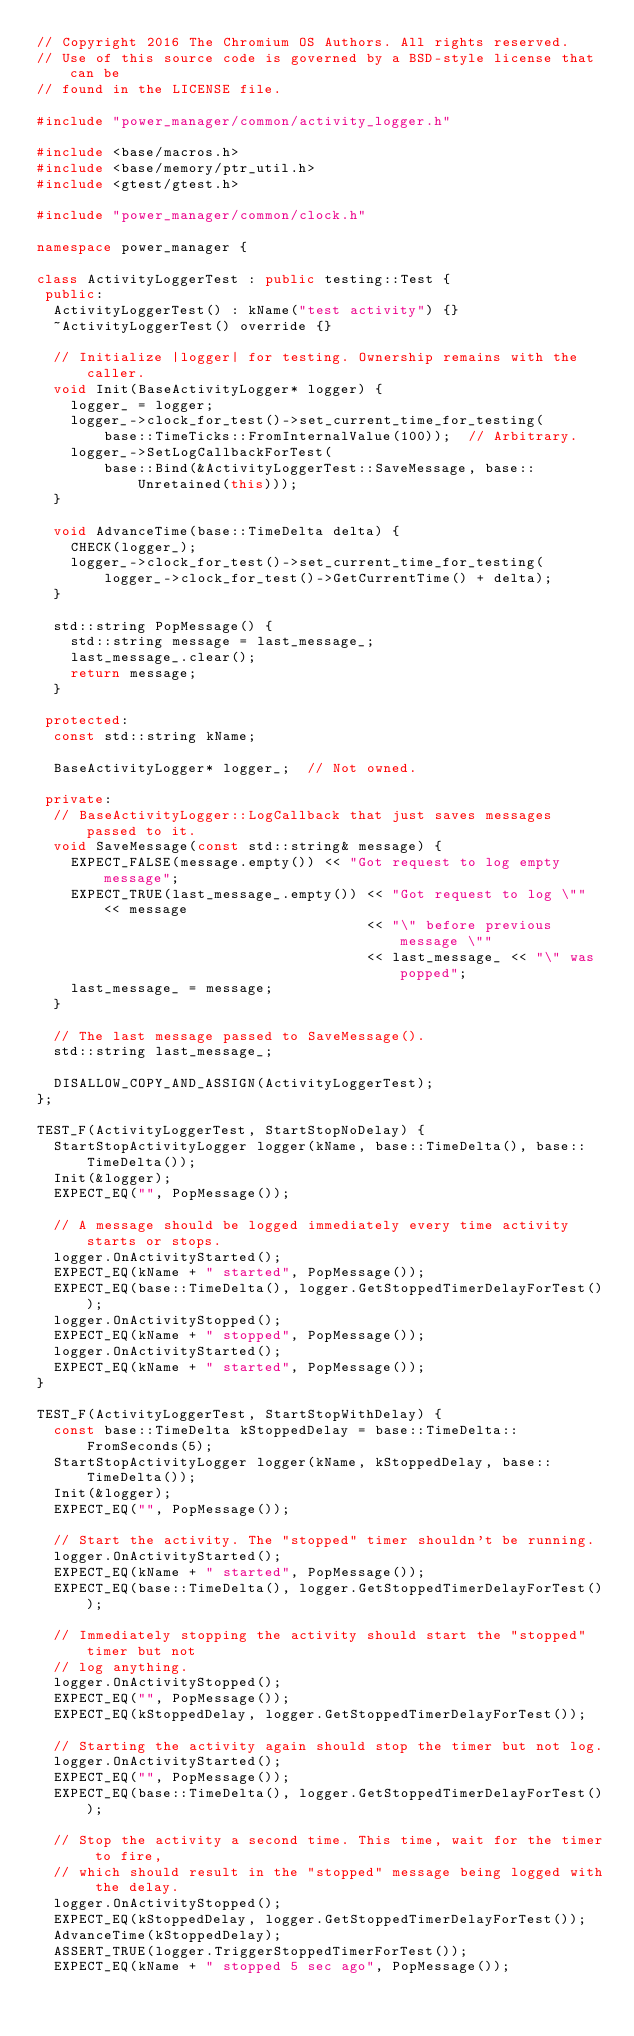Convert code to text. <code><loc_0><loc_0><loc_500><loc_500><_C++_>// Copyright 2016 The Chromium OS Authors. All rights reserved.
// Use of this source code is governed by a BSD-style license that can be
// found in the LICENSE file.

#include "power_manager/common/activity_logger.h"

#include <base/macros.h>
#include <base/memory/ptr_util.h>
#include <gtest/gtest.h>

#include "power_manager/common/clock.h"

namespace power_manager {

class ActivityLoggerTest : public testing::Test {
 public:
  ActivityLoggerTest() : kName("test activity") {}
  ~ActivityLoggerTest() override {}

  // Initialize |logger| for testing. Ownership remains with the caller.
  void Init(BaseActivityLogger* logger) {
    logger_ = logger;
    logger_->clock_for_test()->set_current_time_for_testing(
        base::TimeTicks::FromInternalValue(100));  // Arbitrary.
    logger_->SetLogCallbackForTest(
        base::Bind(&ActivityLoggerTest::SaveMessage, base::Unretained(this)));
  }

  void AdvanceTime(base::TimeDelta delta) {
    CHECK(logger_);
    logger_->clock_for_test()->set_current_time_for_testing(
        logger_->clock_for_test()->GetCurrentTime() + delta);
  }

  std::string PopMessage() {
    std::string message = last_message_;
    last_message_.clear();
    return message;
  }

 protected:
  const std::string kName;

  BaseActivityLogger* logger_;  // Not owned.

 private:
  // BaseActivityLogger::LogCallback that just saves messages passed to it.
  void SaveMessage(const std::string& message) {
    EXPECT_FALSE(message.empty()) << "Got request to log empty message";
    EXPECT_TRUE(last_message_.empty()) << "Got request to log \"" << message
                                       << "\" before previous message \""
                                       << last_message_ << "\" was popped";
    last_message_ = message;
  }

  // The last message passed to SaveMessage().
  std::string last_message_;

  DISALLOW_COPY_AND_ASSIGN(ActivityLoggerTest);
};

TEST_F(ActivityLoggerTest, StartStopNoDelay) {
  StartStopActivityLogger logger(kName, base::TimeDelta(), base::TimeDelta());
  Init(&logger);
  EXPECT_EQ("", PopMessage());

  // A message should be logged immediately every time activity starts or stops.
  logger.OnActivityStarted();
  EXPECT_EQ(kName + " started", PopMessage());
  EXPECT_EQ(base::TimeDelta(), logger.GetStoppedTimerDelayForTest());
  logger.OnActivityStopped();
  EXPECT_EQ(kName + " stopped", PopMessage());
  logger.OnActivityStarted();
  EXPECT_EQ(kName + " started", PopMessage());
}

TEST_F(ActivityLoggerTest, StartStopWithDelay) {
  const base::TimeDelta kStoppedDelay = base::TimeDelta::FromSeconds(5);
  StartStopActivityLogger logger(kName, kStoppedDelay, base::TimeDelta());
  Init(&logger);
  EXPECT_EQ("", PopMessage());

  // Start the activity. The "stopped" timer shouldn't be running.
  logger.OnActivityStarted();
  EXPECT_EQ(kName + " started", PopMessage());
  EXPECT_EQ(base::TimeDelta(), logger.GetStoppedTimerDelayForTest());

  // Immediately stopping the activity should start the "stopped" timer but not
  // log anything.
  logger.OnActivityStopped();
  EXPECT_EQ("", PopMessage());
  EXPECT_EQ(kStoppedDelay, logger.GetStoppedTimerDelayForTest());

  // Starting the activity again should stop the timer but not log.
  logger.OnActivityStarted();
  EXPECT_EQ("", PopMessage());
  EXPECT_EQ(base::TimeDelta(), logger.GetStoppedTimerDelayForTest());

  // Stop the activity a second time. This time, wait for the timer to fire,
  // which should result in the "stopped" message being logged with the delay.
  logger.OnActivityStopped();
  EXPECT_EQ(kStoppedDelay, logger.GetStoppedTimerDelayForTest());
  AdvanceTime(kStoppedDelay);
  ASSERT_TRUE(logger.TriggerStoppedTimerForTest());
  EXPECT_EQ(kName + " stopped 5 sec ago", PopMessage());
</code> 